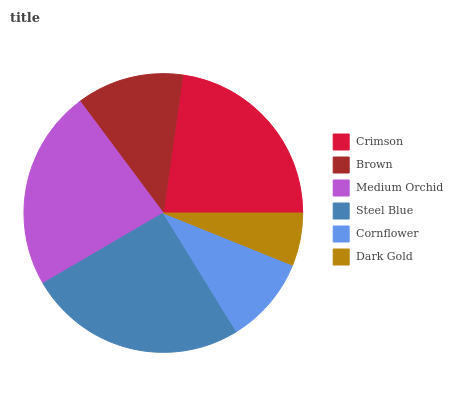Is Dark Gold the minimum?
Answer yes or no. Yes. Is Steel Blue the maximum?
Answer yes or no. Yes. Is Brown the minimum?
Answer yes or no. No. Is Brown the maximum?
Answer yes or no. No. Is Crimson greater than Brown?
Answer yes or no. Yes. Is Brown less than Crimson?
Answer yes or no. Yes. Is Brown greater than Crimson?
Answer yes or no. No. Is Crimson less than Brown?
Answer yes or no. No. Is Crimson the high median?
Answer yes or no. Yes. Is Brown the low median?
Answer yes or no. Yes. Is Cornflower the high median?
Answer yes or no. No. Is Medium Orchid the low median?
Answer yes or no. No. 